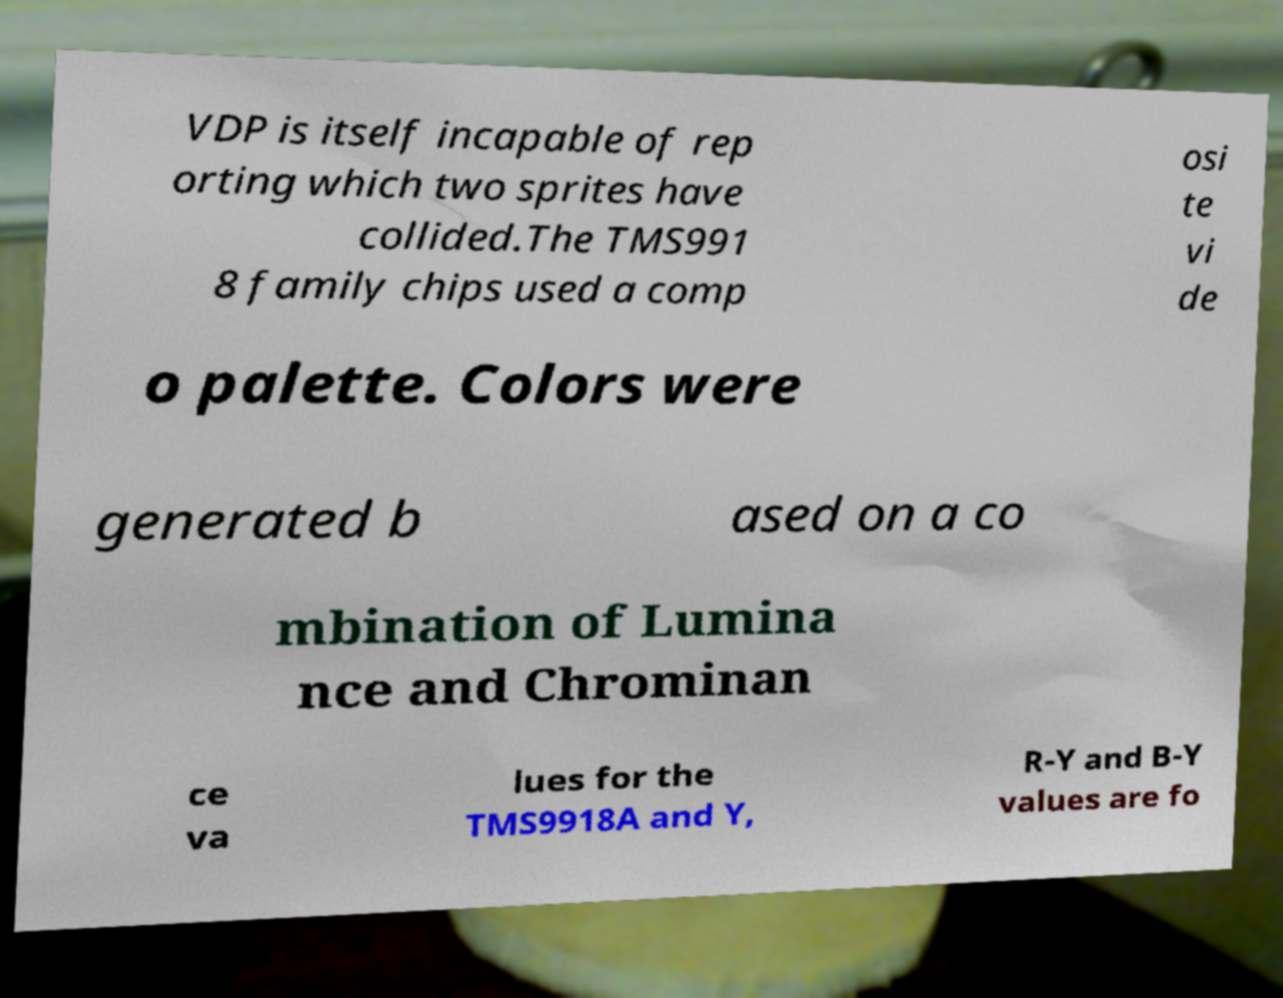Please read and relay the text visible in this image. What does it say? VDP is itself incapable of rep orting which two sprites have collided.The TMS991 8 family chips used a comp osi te vi de o palette. Colors were generated b ased on a co mbination of Lumina nce and Chrominan ce va lues for the TMS9918A and Y, R-Y and B-Y values are fo 